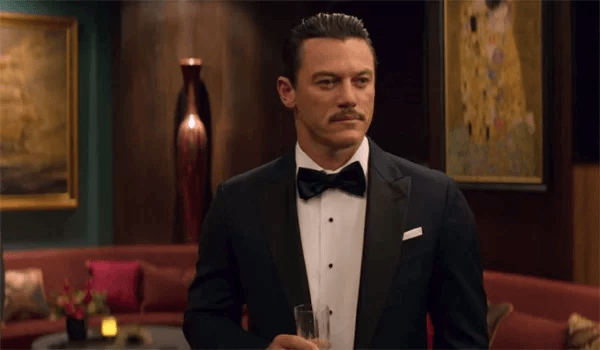Can you describe the mood set by the room's decor? The room's decor, with its deep red walls and gold accents, creates a warm yet regal atmosphere, suggesting luxury and exclusivity. Such a setting typically indicates a high-profile gathering or an environment intended for significant social interactions, possibly a gala, award ceremony, or a formal reception. 